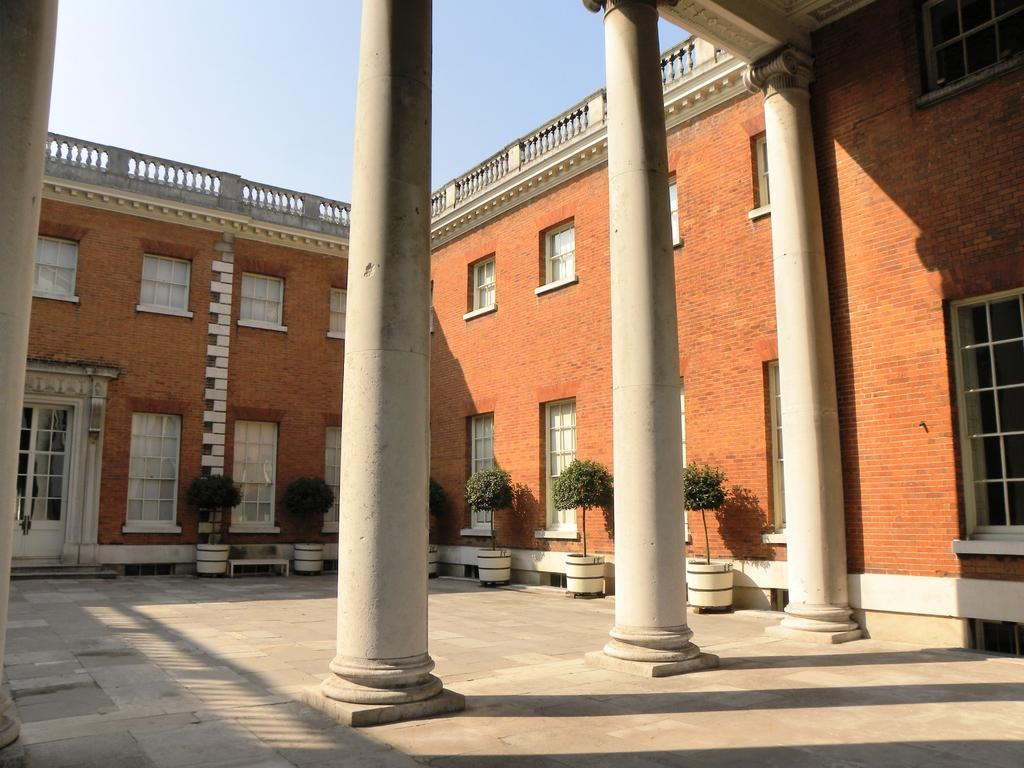What type of structure is present in the image? There is a building in the image. What architectural feature can be seen on the building? There are pillars in the image. Are there any plants visible in the image? Yes, there are plants in pots in the image. What can be seen below the building in the image? The ground is visible in the image. What is visible above the building in the image? The sky is visible in the image. Can you see a key hanging from one of the pillars in the image? There is no key visible hanging from any of the pillars in the image. Are there any wrens flying around the plants in the image? There are no wrens present in the image; only plants in pots are visible. 